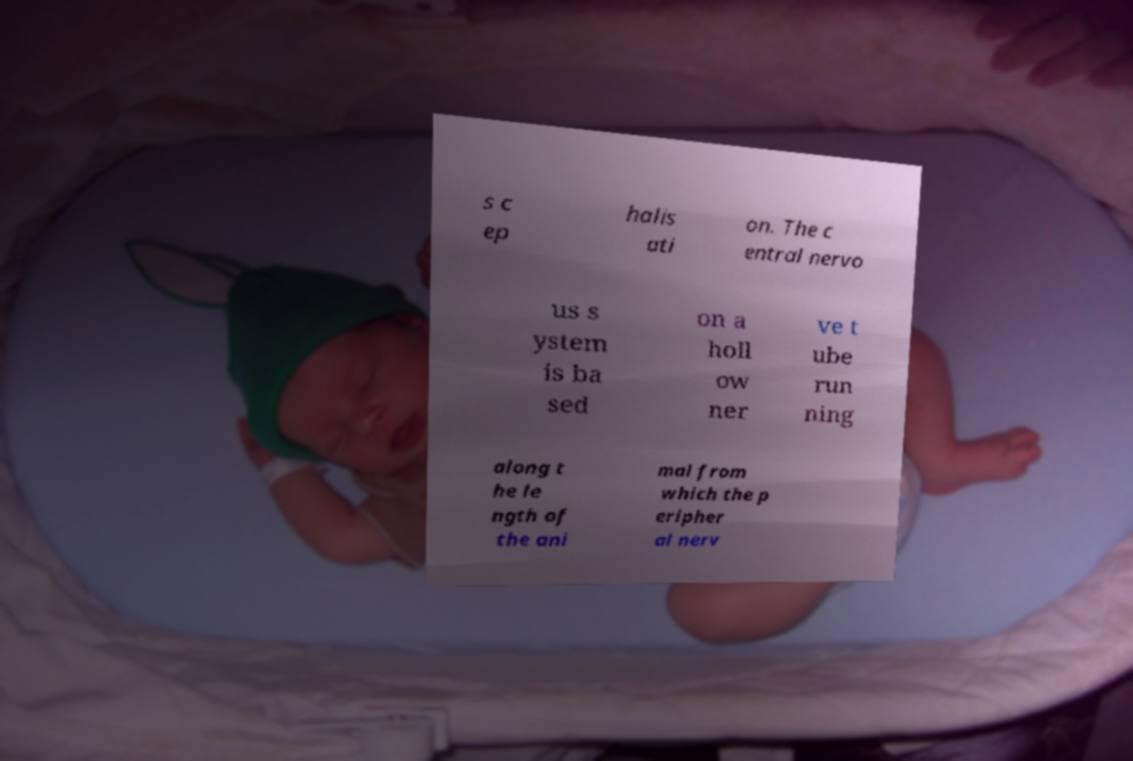Can you read and provide the text displayed in the image?This photo seems to have some interesting text. Can you extract and type it out for me? s c ep halis ati on. The c entral nervo us s ystem is ba sed on a holl ow ner ve t ube run ning along t he le ngth of the ani mal from which the p eripher al nerv 